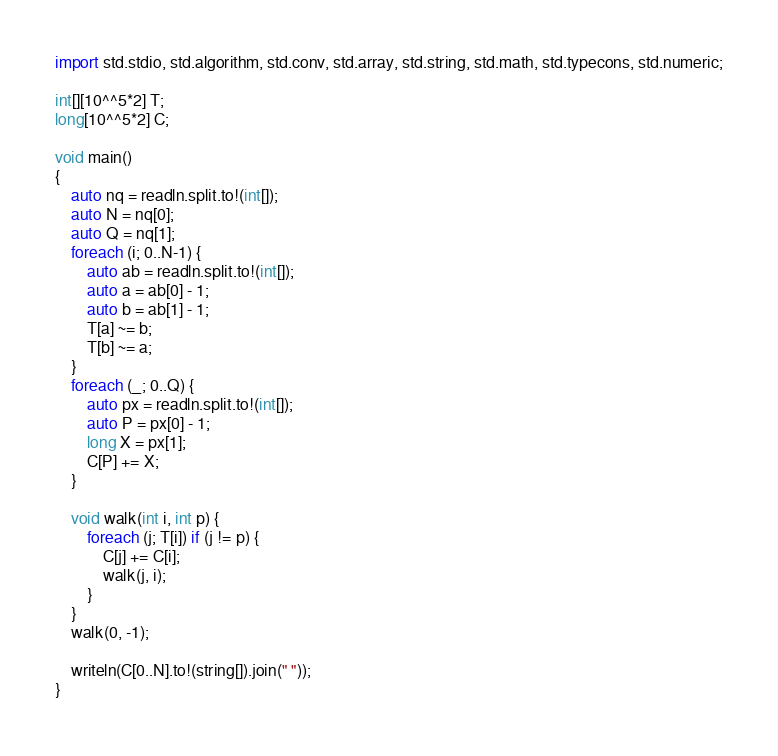Convert code to text. <code><loc_0><loc_0><loc_500><loc_500><_D_>import std.stdio, std.algorithm, std.conv, std.array, std.string, std.math, std.typecons, std.numeric;

int[][10^^5*2] T;
long[10^^5*2] C;

void main()
{
    auto nq = readln.split.to!(int[]);
    auto N = nq[0];
    auto Q = nq[1];
    foreach (i; 0..N-1) {
        auto ab = readln.split.to!(int[]);
        auto a = ab[0] - 1;
        auto b = ab[1] - 1;
        T[a] ~= b;
        T[b] ~= a;
    }
    foreach (_; 0..Q) {
        auto px = readln.split.to!(int[]);
        auto P = px[0] - 1;
        long X = px[1];
        C[P] += X;
    }

    void walk(int i, int p) {
        foreach (j; T[i]) if (j != p) {
            C[j] += C[i];
            walk(j, i);
        }
    }
    walk(0, -1);

    writeln(C[0..N].to!(string[]).join(" "));
}</code> 